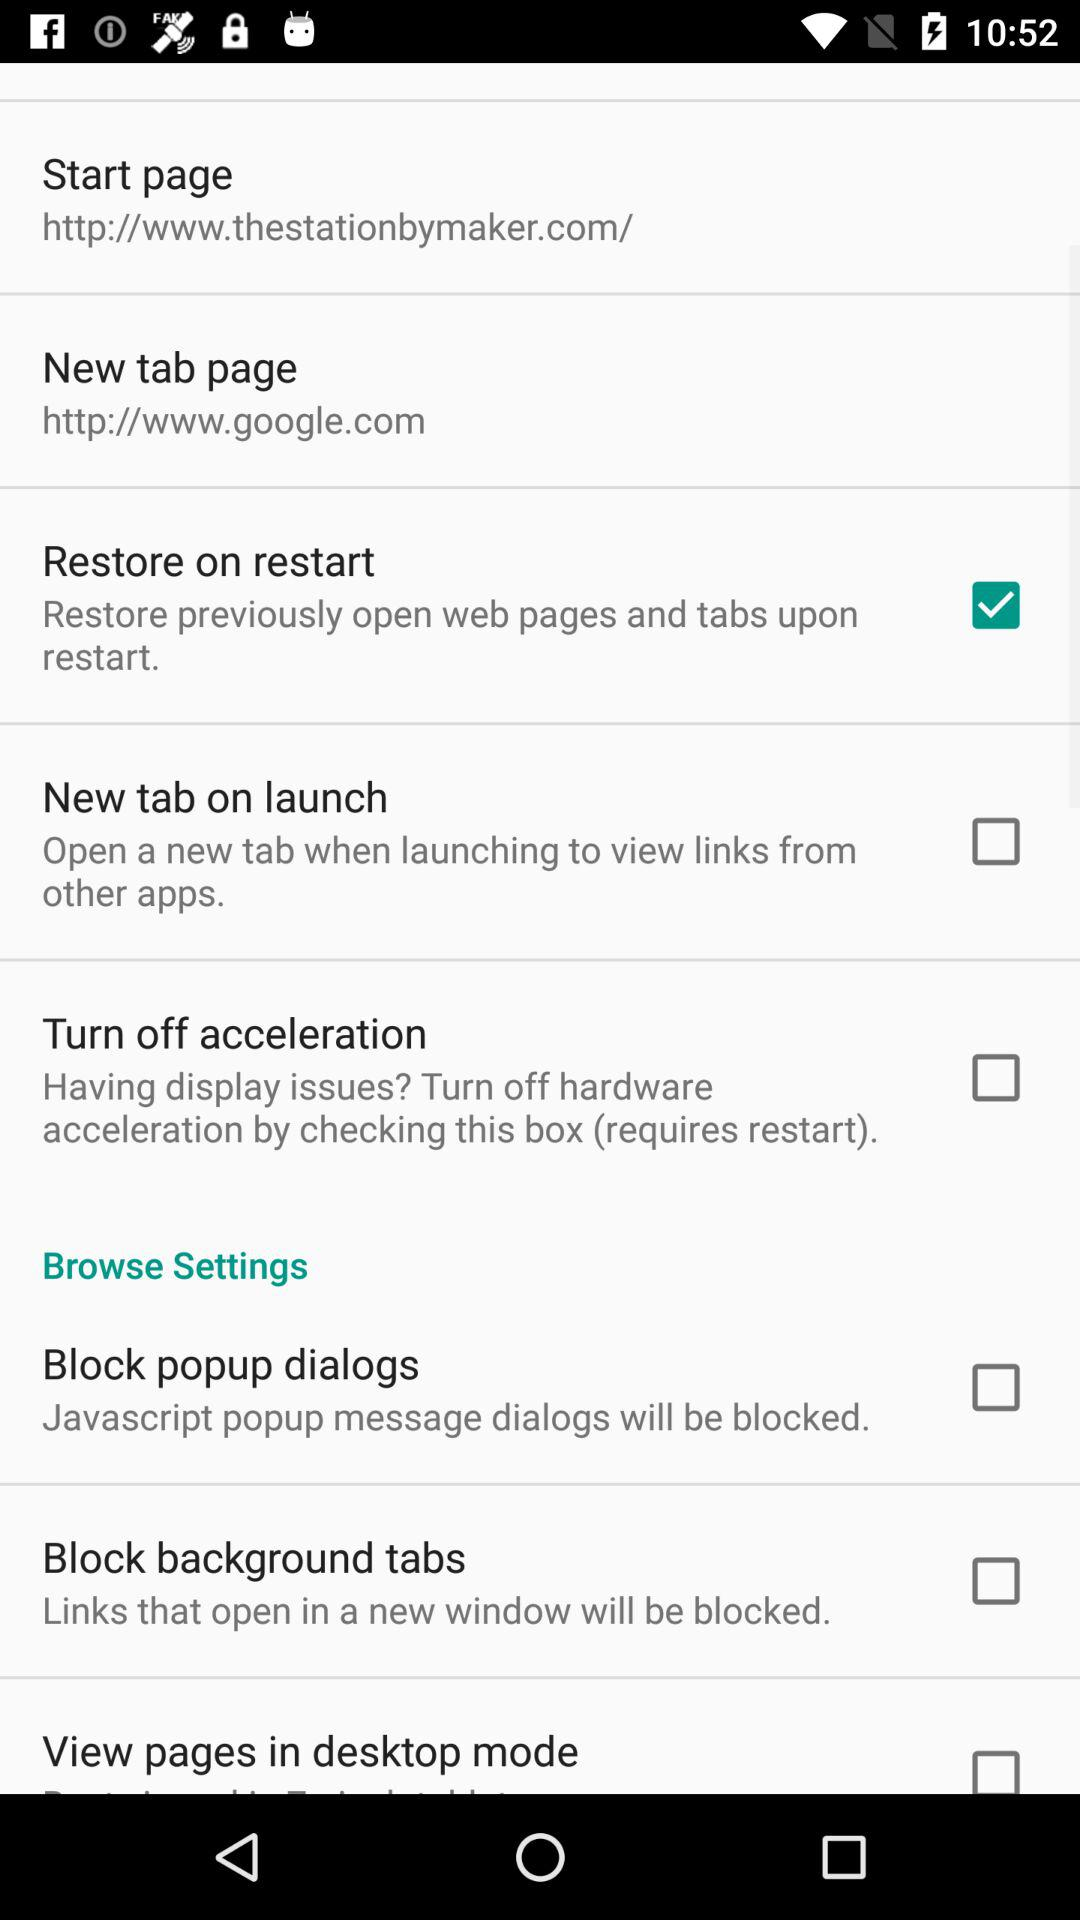What is the URL of the new tab page? The URL of the new tab page is "http://www.google.com". 